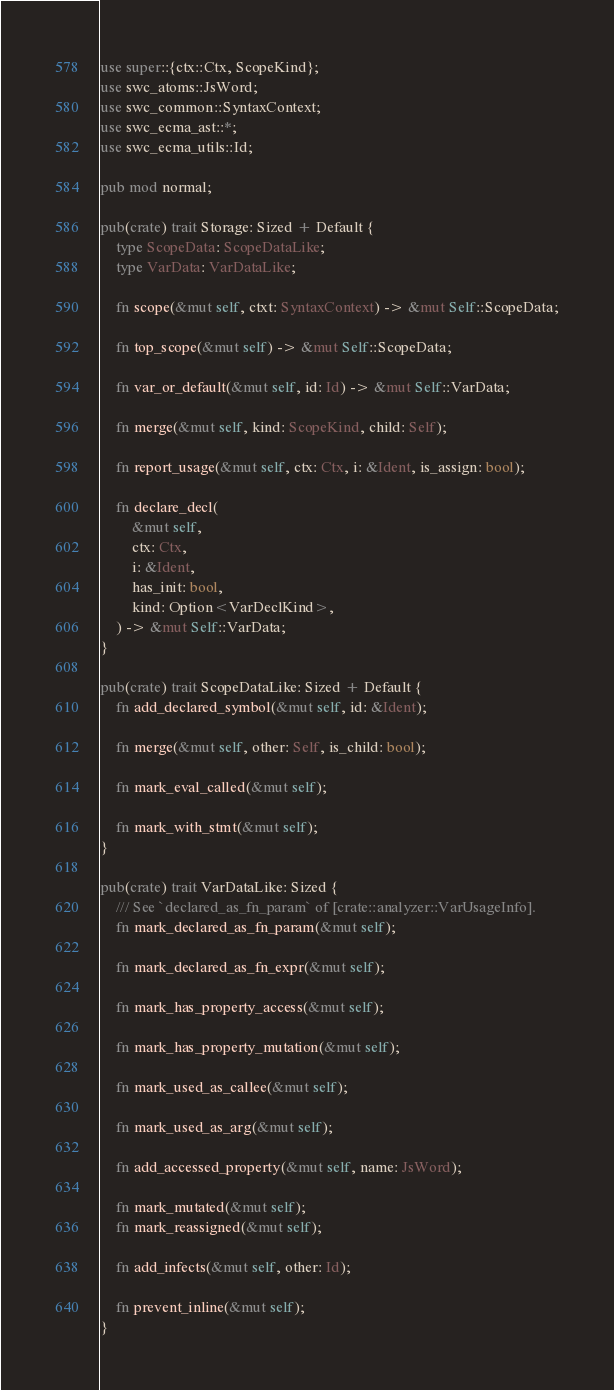Convert code to text. <code><loc_0><loc_0><loc_500><loc_500><_Rust_>use super::{ctx::Ctx, ScopeKind};
use swc_atoms::JsWord;
use swc_common::SyntaxContext;
use swc_ecma_ast::*;
use swc_ecma_utils::Id;

pub mod normal;

pub(crate) trait Storage: Sized + Default {
    type ScopeData: ScopeDataLike;
    type VarData: VarDataLike;

    fn scope(&mut self, ctxt: SyntaxContext) -> &mut Self::ScopeData;

    fn top_scope(&mut self) -> &mut Self::ScopeData;

    fn var_or_default(&mut self, id: Id) -> &mut Self::VarData;

    fn merge(&mut self, kind: ScopeKind, child: Self);

    fn report_usage(&mut self, ctx: Ctx, i: &Ident, is_assign: bool);

    fn declare_decl(
        &mut self,
        ctx: Ctx,
        i: &Ident,
        has_init: bool,
        kind: Option<VarDeclKind>,
    ) -> &mut Self::VarData;
}

pub(crate) trait ScopeDataLike: Sized + Default {
    fn add_declared_symbol(&mut self, id: &Ident);

    fn merge(&mut self, other: Self, is_child: bool);

    fn mark_eval_called(&mut self);

    fn mark_with_stmt(&mut self);
}

pub(crate) trait VarDataLike: Sized {
    /// See `declared_as_fn_param` of [crate::analyzer::VarUsageInfo].
    fn mark_declared_as_fn_param(&mut self);

    fn mark_declared_as_fn_expr(&mut self);

    fn mark_has_property_access(&mut self);

    fn mark_has_property_mutation(&mut self);

    fn mark_used_as_callee(&mut self);

    fn mark_used_as_arg(&mut self);

    fn add_accessed_property(&mut self, name: JsWord);

    fn mark_mutated(&mut self);
    fn mark_reassigned(&mut self);

    fn add_infects(&mut self, other: Id);

    fn prevent_inline(&mut self);
}
</code> 